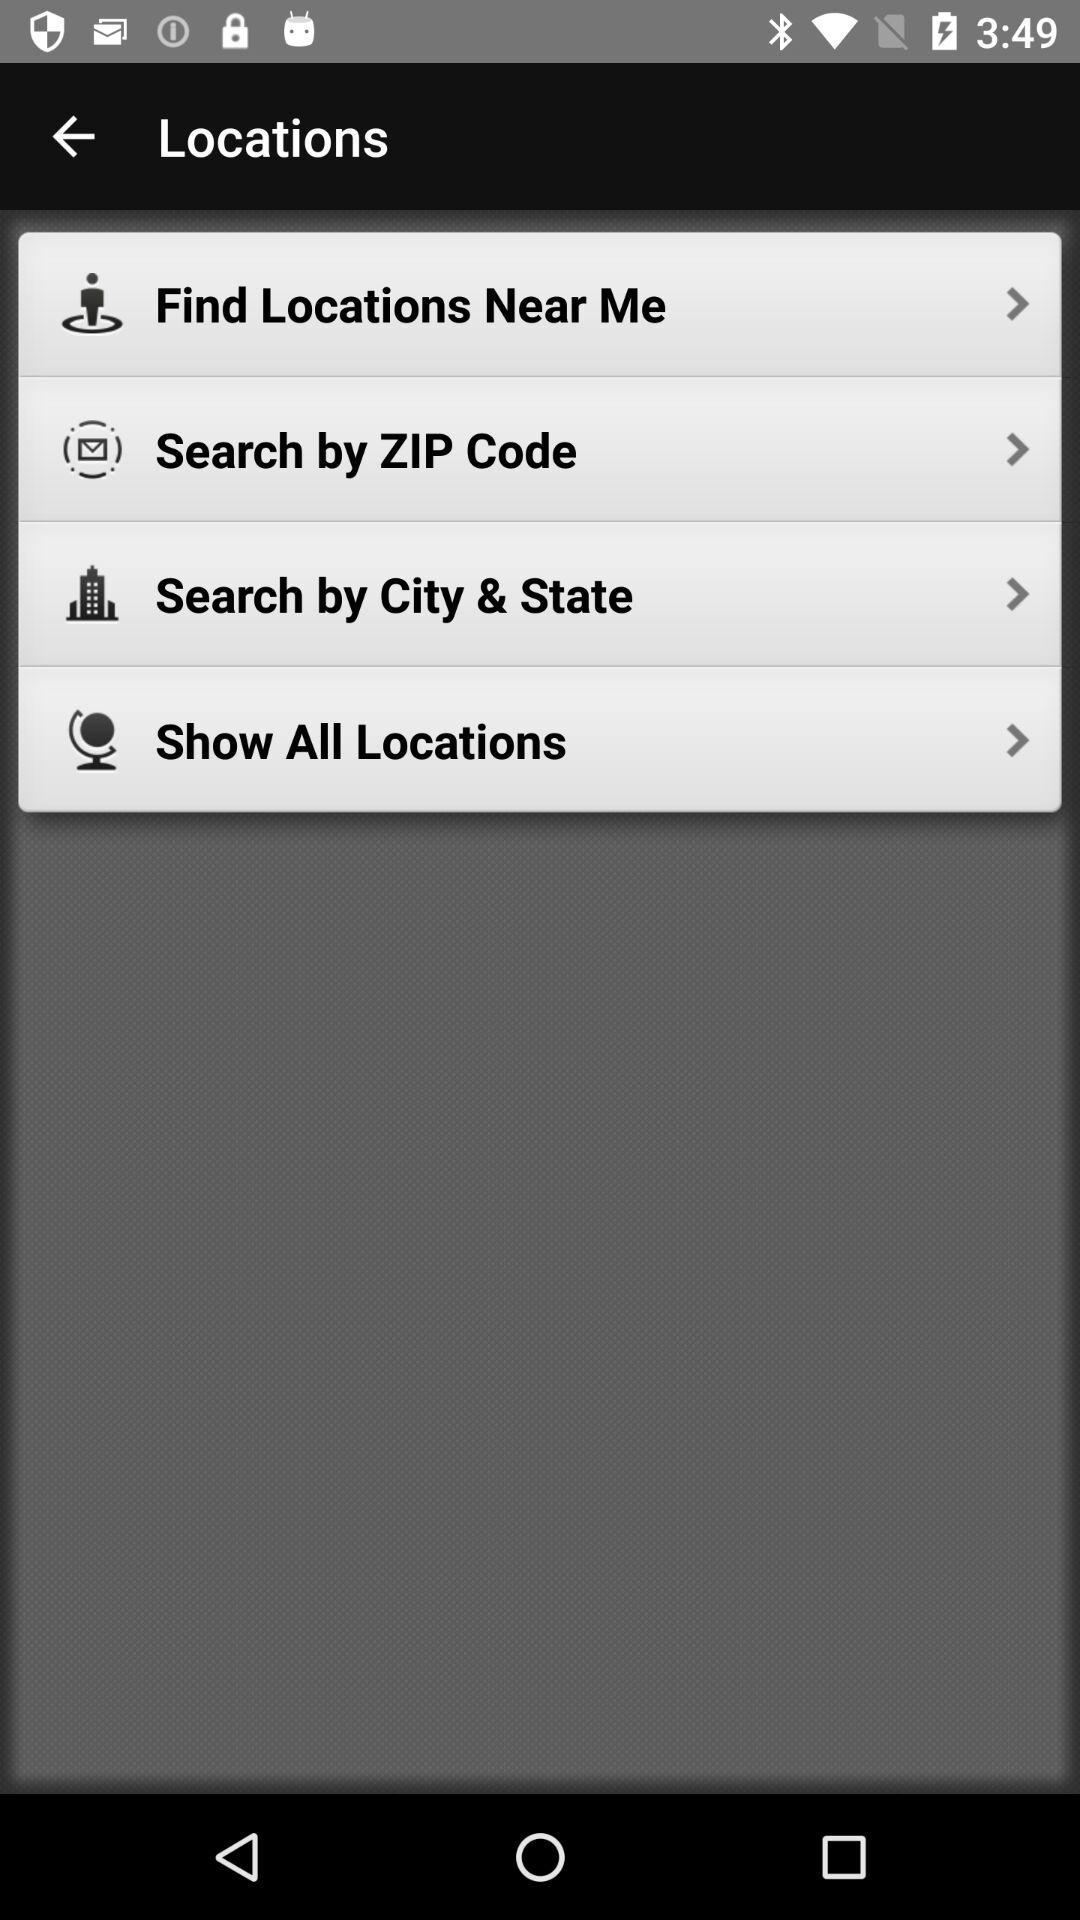How many items have a forward arrow?
Answer the question using a single word or phrase. 4 